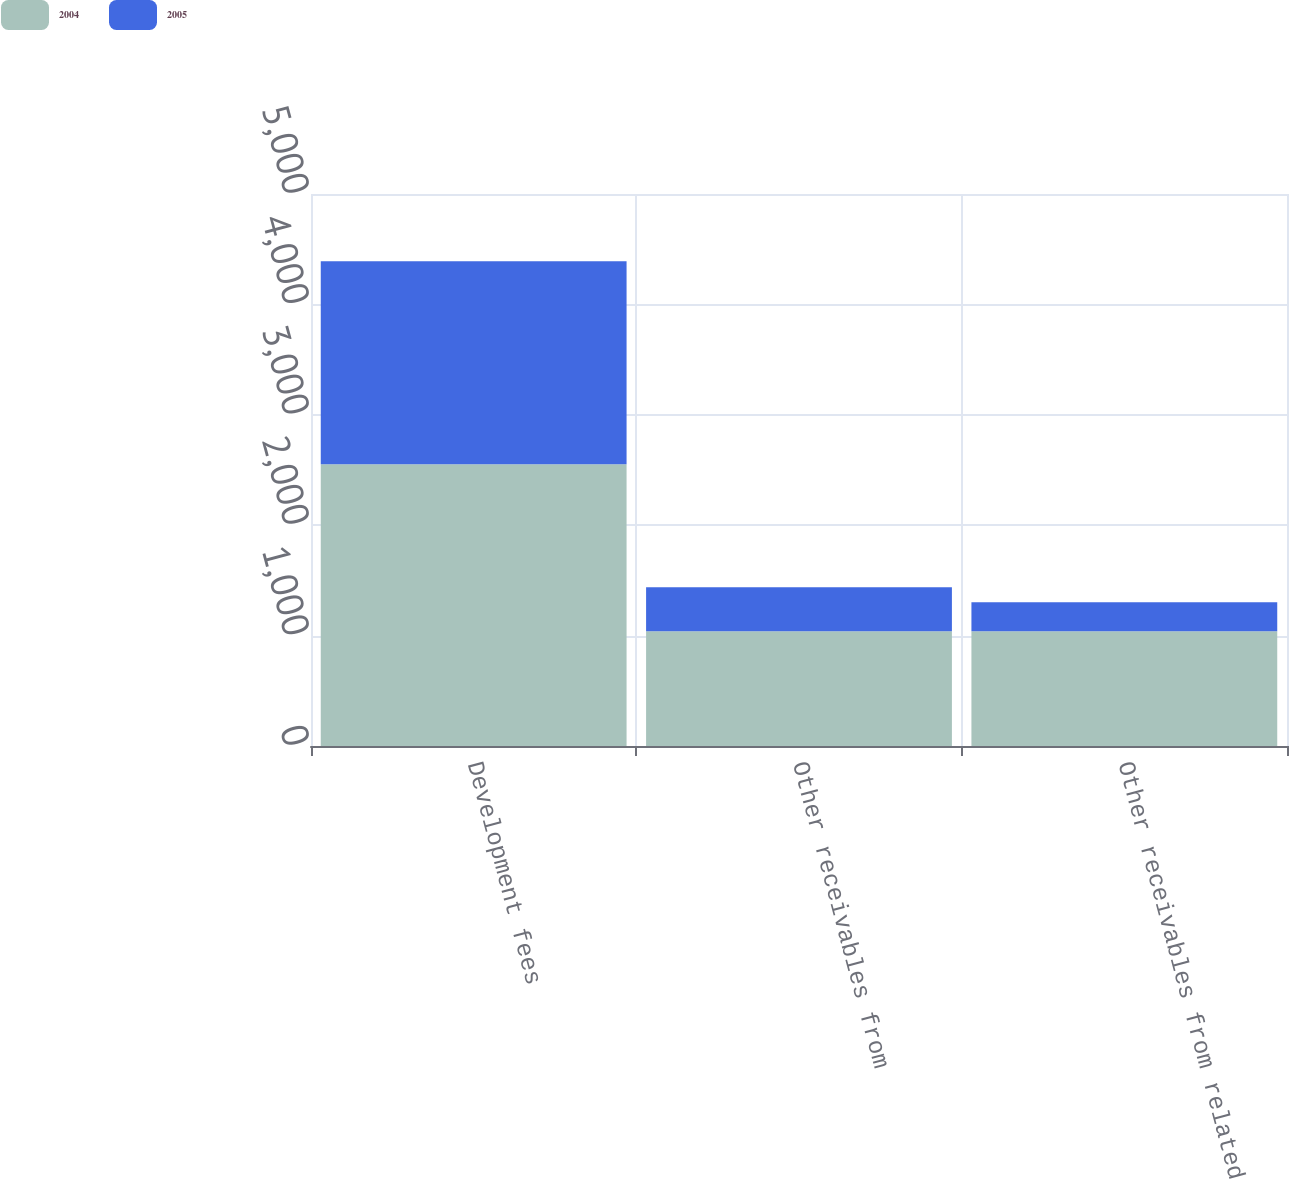Convert chart. <chart><loc_0><loc_0><loc_500><loc_500><stacked_bar_chart><ecel><fcel>Development fees<fcel>Other receivables from<fcel>Other receivables from related<nl><fcel>2004<fcel>2552<fcel>1039<fcel>1039<nl><fcel>2005<fcel>1839<fcel>400<fcel>262<nl></chart> 